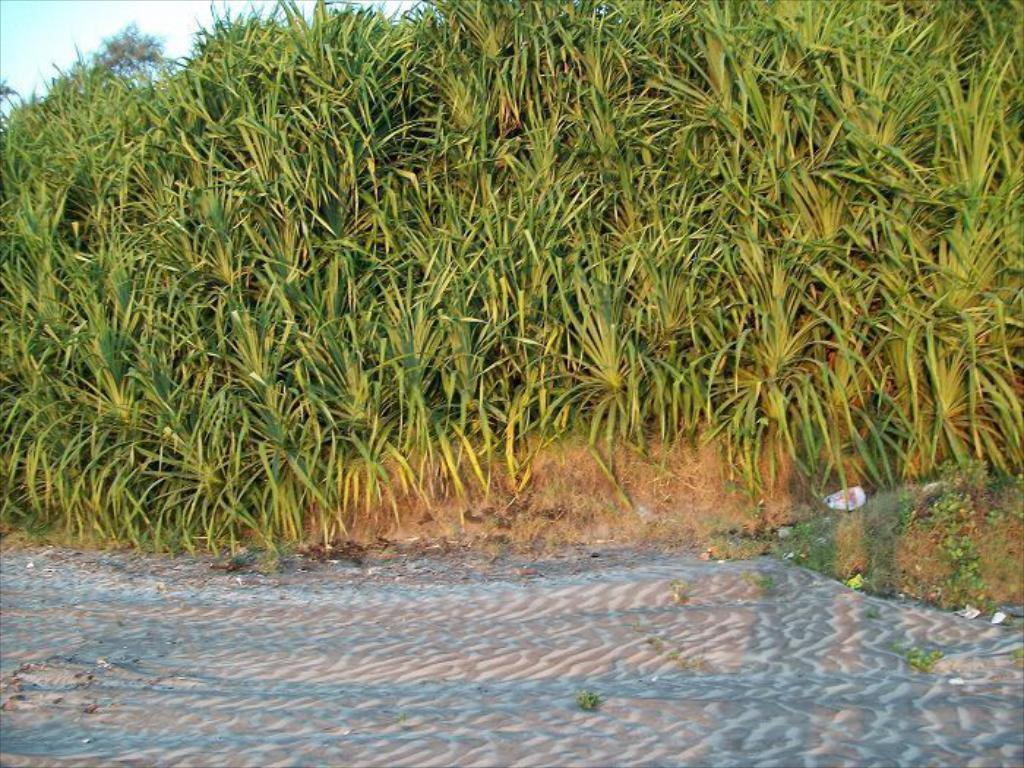What type of surface is visible in the image? There is a surface of sand in the image. What is located in front of the sand? There are crops in front of the sand. What else can be seen in the image besides the sand and crops? The sky is visible in the image. Where is the cable connected to in the image? There is no cable present in the image. How many times does the person on the stage sneeze in the image? There is no person on a stage present in the image. 